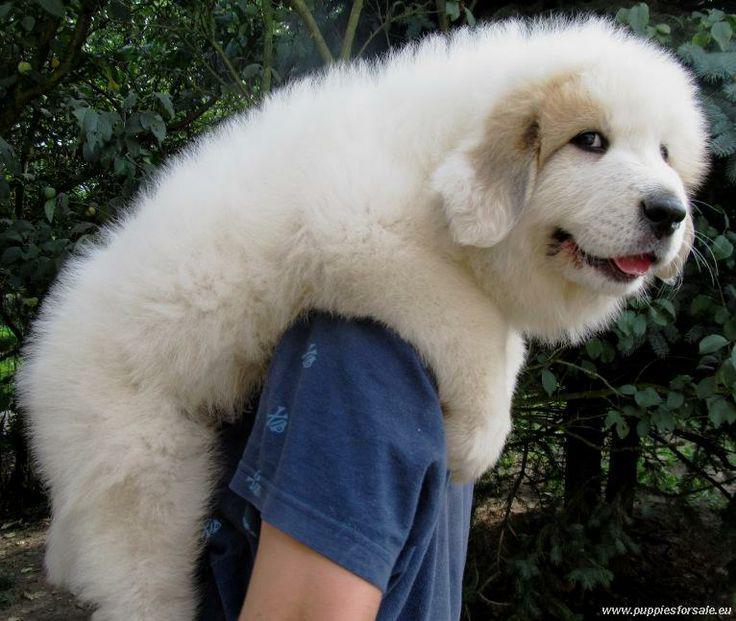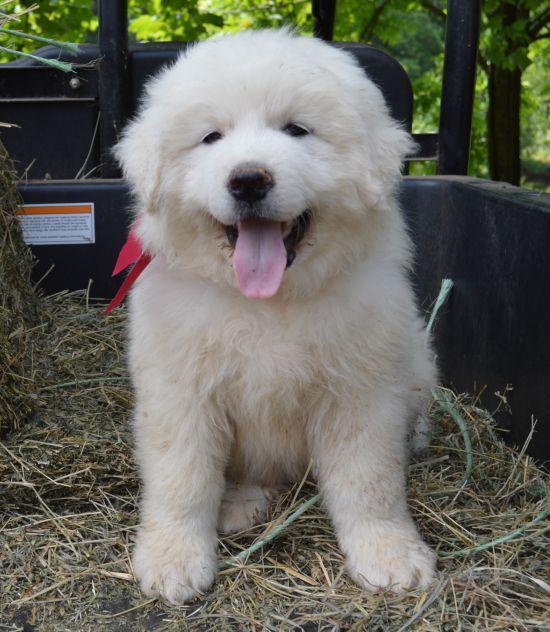The first image is the image on the left, the second image is the image on the right. Considering the images on both sides, is "At least one dog has a brown spot." valid? Answer yes or no. Yes. 